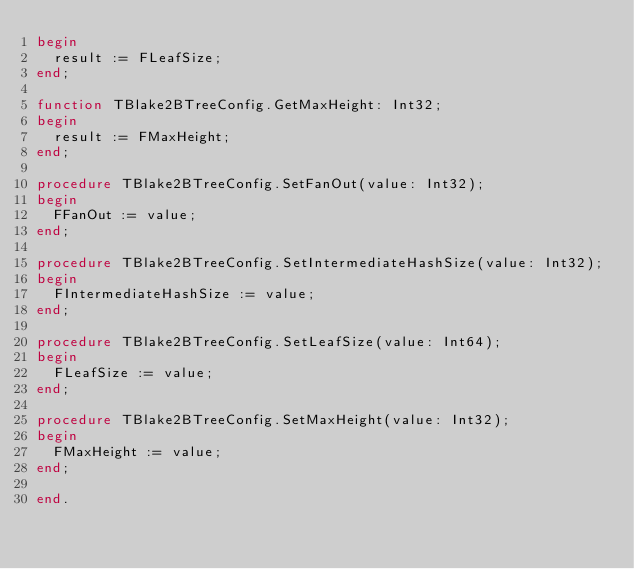<code> <loc_0><loc_0><loc_500><loc_500><_Pascal_>begin
  result := FLeafSize;
end;

function TBlake2BTreeConfig.GetMaxHeight: Int32;
begin
  result := FMaxHeight;
end;

procedure TBlake2BTreeConfig.SetFanOut(value: Int32);
begin
  FFanOut := value;
end;

procedure TBlake2BTreeConfig.SetIntermediateHashSize(value: Int32);
begin
  FIntermediateHashSize := value;
end;

procedure TBlake2BTreeConfig.SetLeafSize(value: Int64);
begin
  FLeafSize := value;
end;

procedure TBlake2BTreeConfig.SetMaxHeight(value: Int32);
begin
  FMaxHeight := value;
end;

end.
</code> 